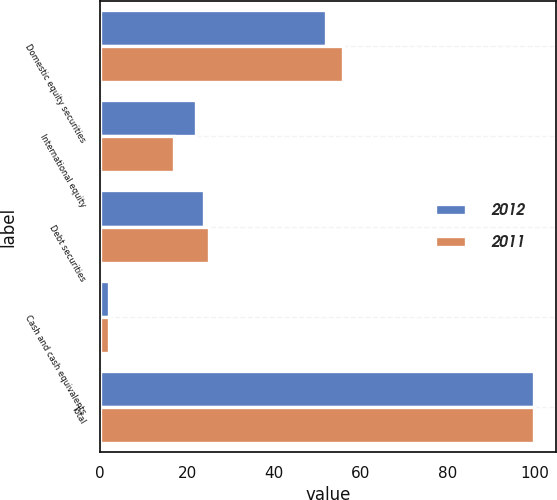<chart> <loc_0><loc_0><loc_500><loc_500><stacked_bar_chart><ecel><fcel>Domestic equity securities<fcel>International equity<fcel>Debt securities<fcel>Cash and cash equivalents<fcel>Total<nl><fcel>2012<fcel>52<fcel>22<fcel>24<fcel>2<fcel>100<nl><fcel>2011<fcel>56<fcel>17<fcel>25<fcel>2<fcel>100<nl></chart> 